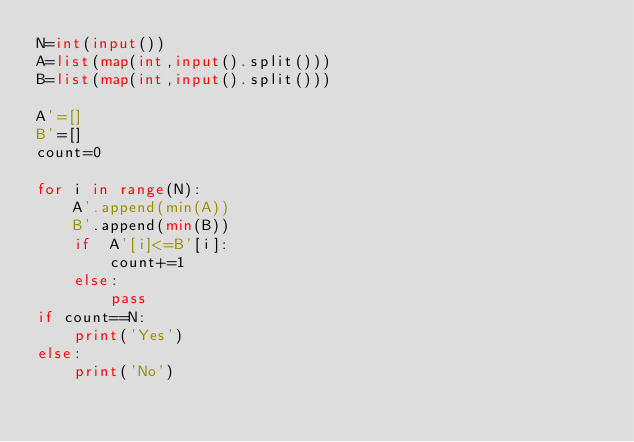Convert code to text. <code><loc_0><loc_0><loc_500><loc_500><_Python_>N=int(input())
A=list(map(int,input().split()))
B=list(map(int,input().split()))

A'=[]
B'=[]
count=0

for i in range(N):
    A'.append(min(A))
    B'.append(min(B))
    if  A'[i]<=B'[i]:
        count+=1
    else:
        pass
if count==N:
    print('Yes')
else:
    print('No')
</code> 